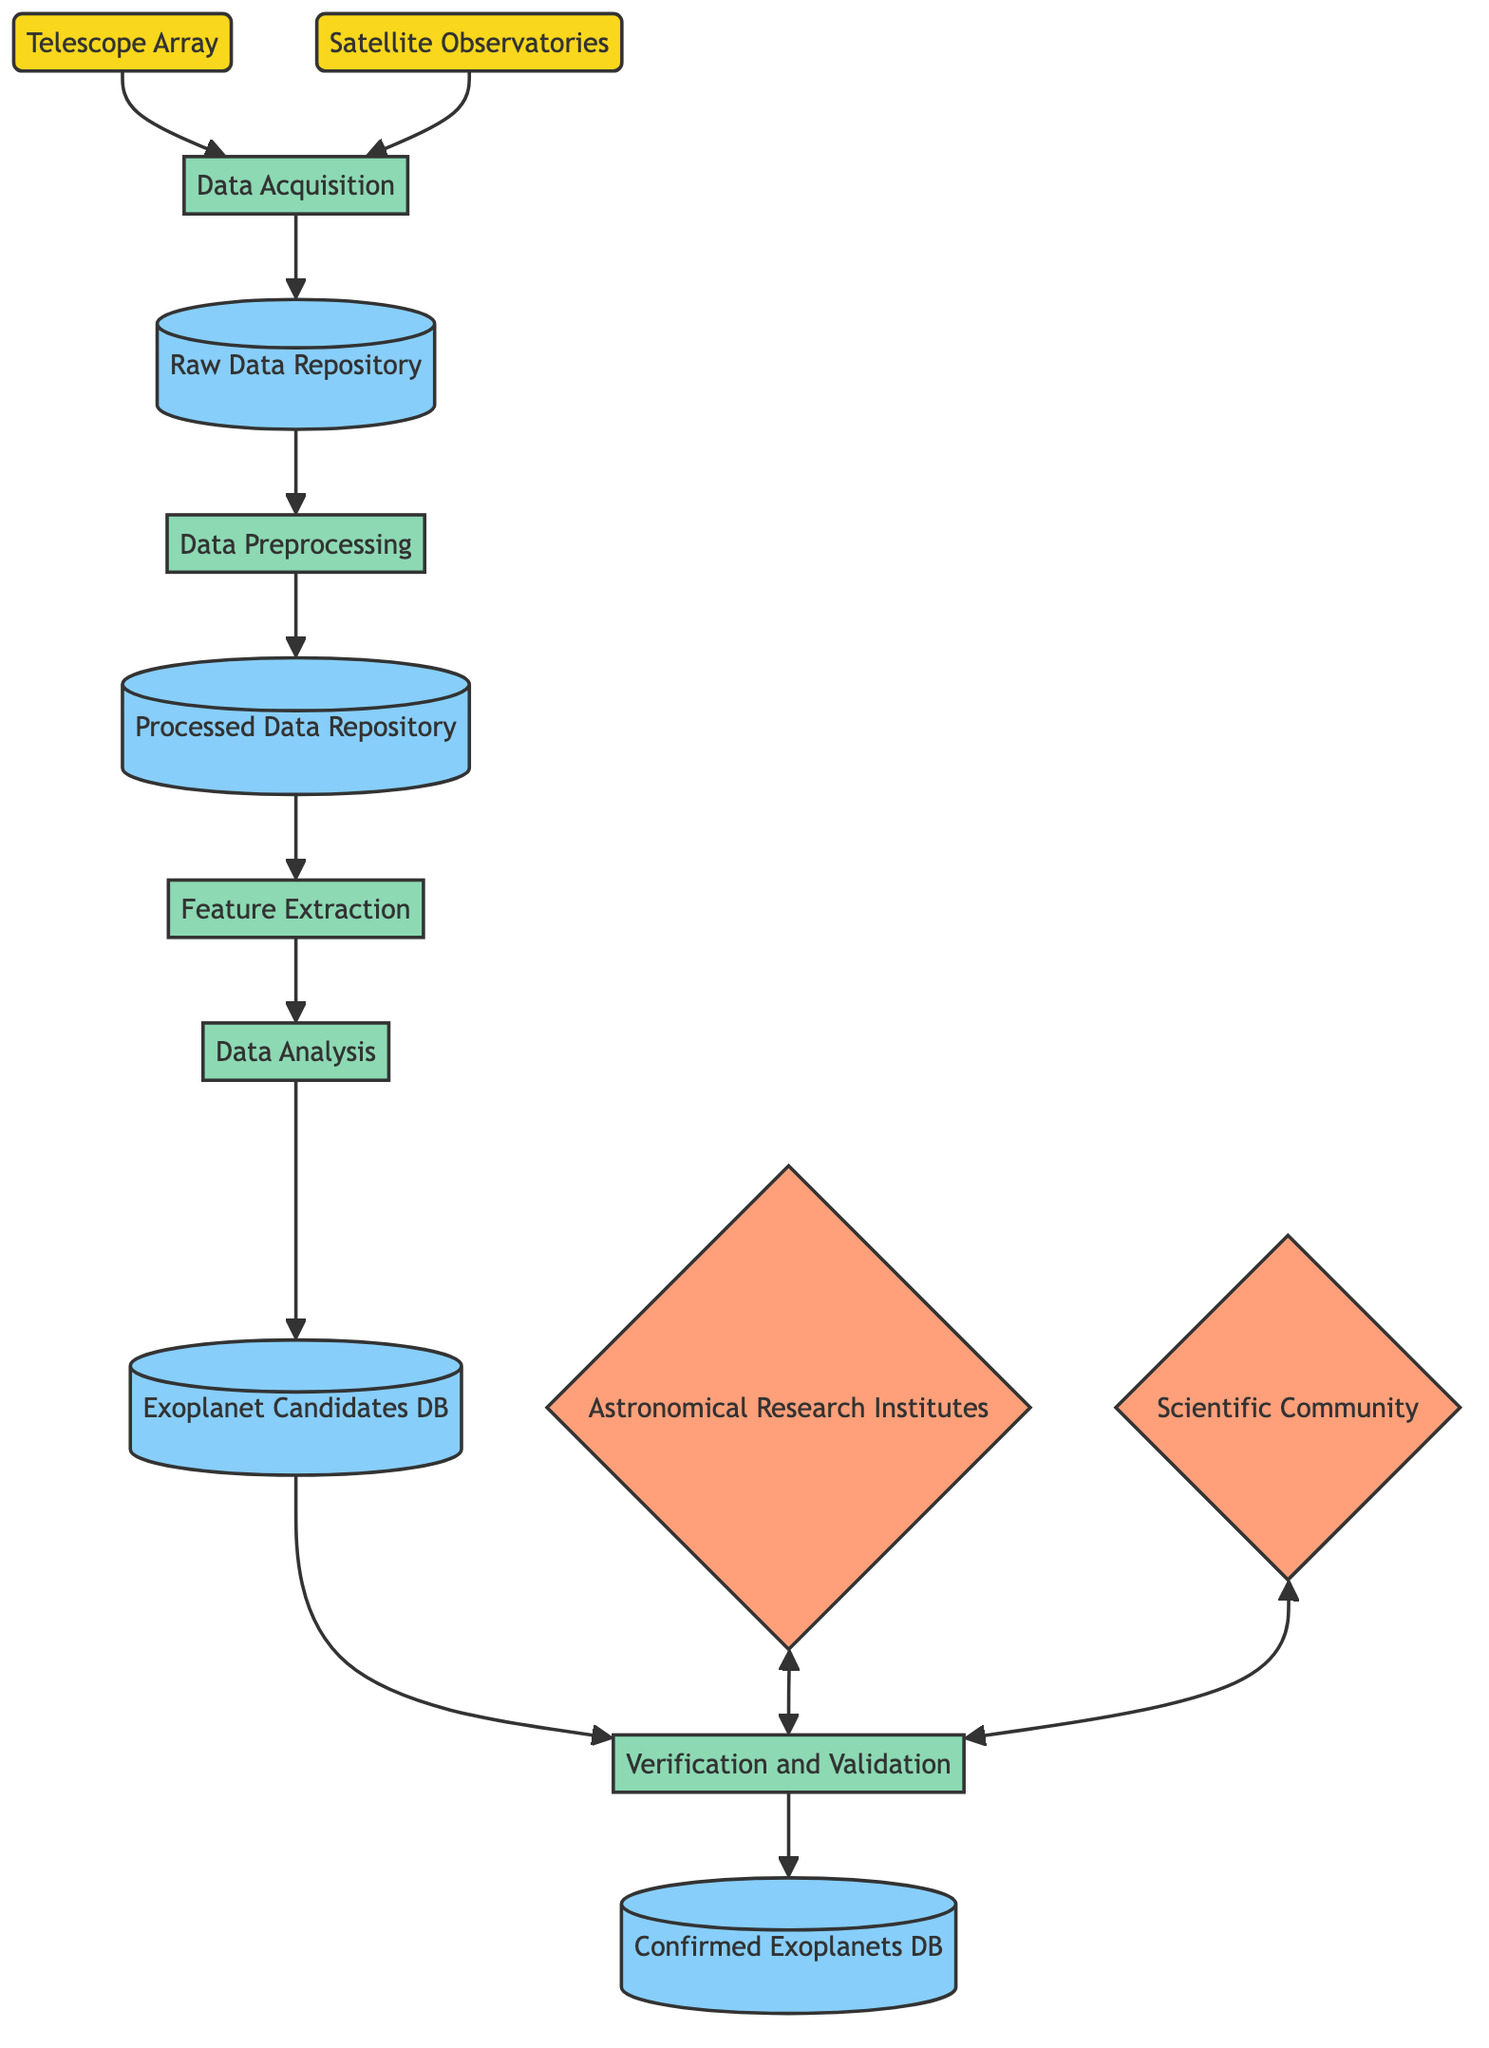What are the two sources of astronomical data? The diagram shows two sources: the Telescope Array and Satellite Observatories. They are represented as nodes labeled with these names, indicating where the data originates.
Answer: Telescope Array, Satellite Observatories How many processes are involved in the data flow? The diagram includes five distinct processes: Data Acquisition, Data Preprocessing, Feature Extraction, Data Analysis, and Verification and Validation. Counting these processes gives a total of five.
Answer: Five What is the role of the Raw Data Repository? The Raw Data Repository is where the unprocessed observational data from telescopes and observatories is stored after Data Acquisition is completed. It is directly connected to the Data Acquisition process in the diagram.
Answer: Storage of unprocessed observational data Which external entities are involved in the verification process? The diagram shows two external entities that interact with the Verification and Validation process: Astronomical Research Institutes and the Scientific Community. They are depicted with bidirectional arrows indicating collaboration and communication.
Answer: Astronomical Research Institutes, Scientific Community What data store holds confirmed exoplanet discoveries? The data store labeled Confirmed Exoplanets Database specifically lists the verified exoplanet discoveries according to the indications in the diagram.
Answer: Confirmed Exoplanets Database Which process directly follows Data Preprocessing? After the Data Preprocessing step, the next process in the flow is Feature Extraction. The diagram shows an arrow connecting these two processes, indicating the flow of data.
Answer: Feature Extraction What process applies statistical and machine learning models? The process that applies statistical and machine learning models to identify potential exoplanets is Data Analysis. This is outlined in the diagram with a direct connection to the Feature Extraction process.
Answer: Data Analysis How many data repositories are shown in the diagram? There are four data repositories in the diagram: Raw Data Repository, Processed Data Repository, Exoplanet Candidates Database, and Confirmed Exoplanets Database. Counting these repositories results in a total of four.
Answer: Four Which process leads to the Exoplanet Candidates Database? The process leading to the Exoplanet Candidates Database is Data Analysis. The flow diagram illustrates that Data Analysis outputs findings that are stored in this database.
Answer: Data Analysis 